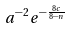<formula> <loc_0><loc_0><loc_500><loc_500>a ^ { - 2 } e ^ { - \frac { 8 c } { 8 - n } }</formula> 